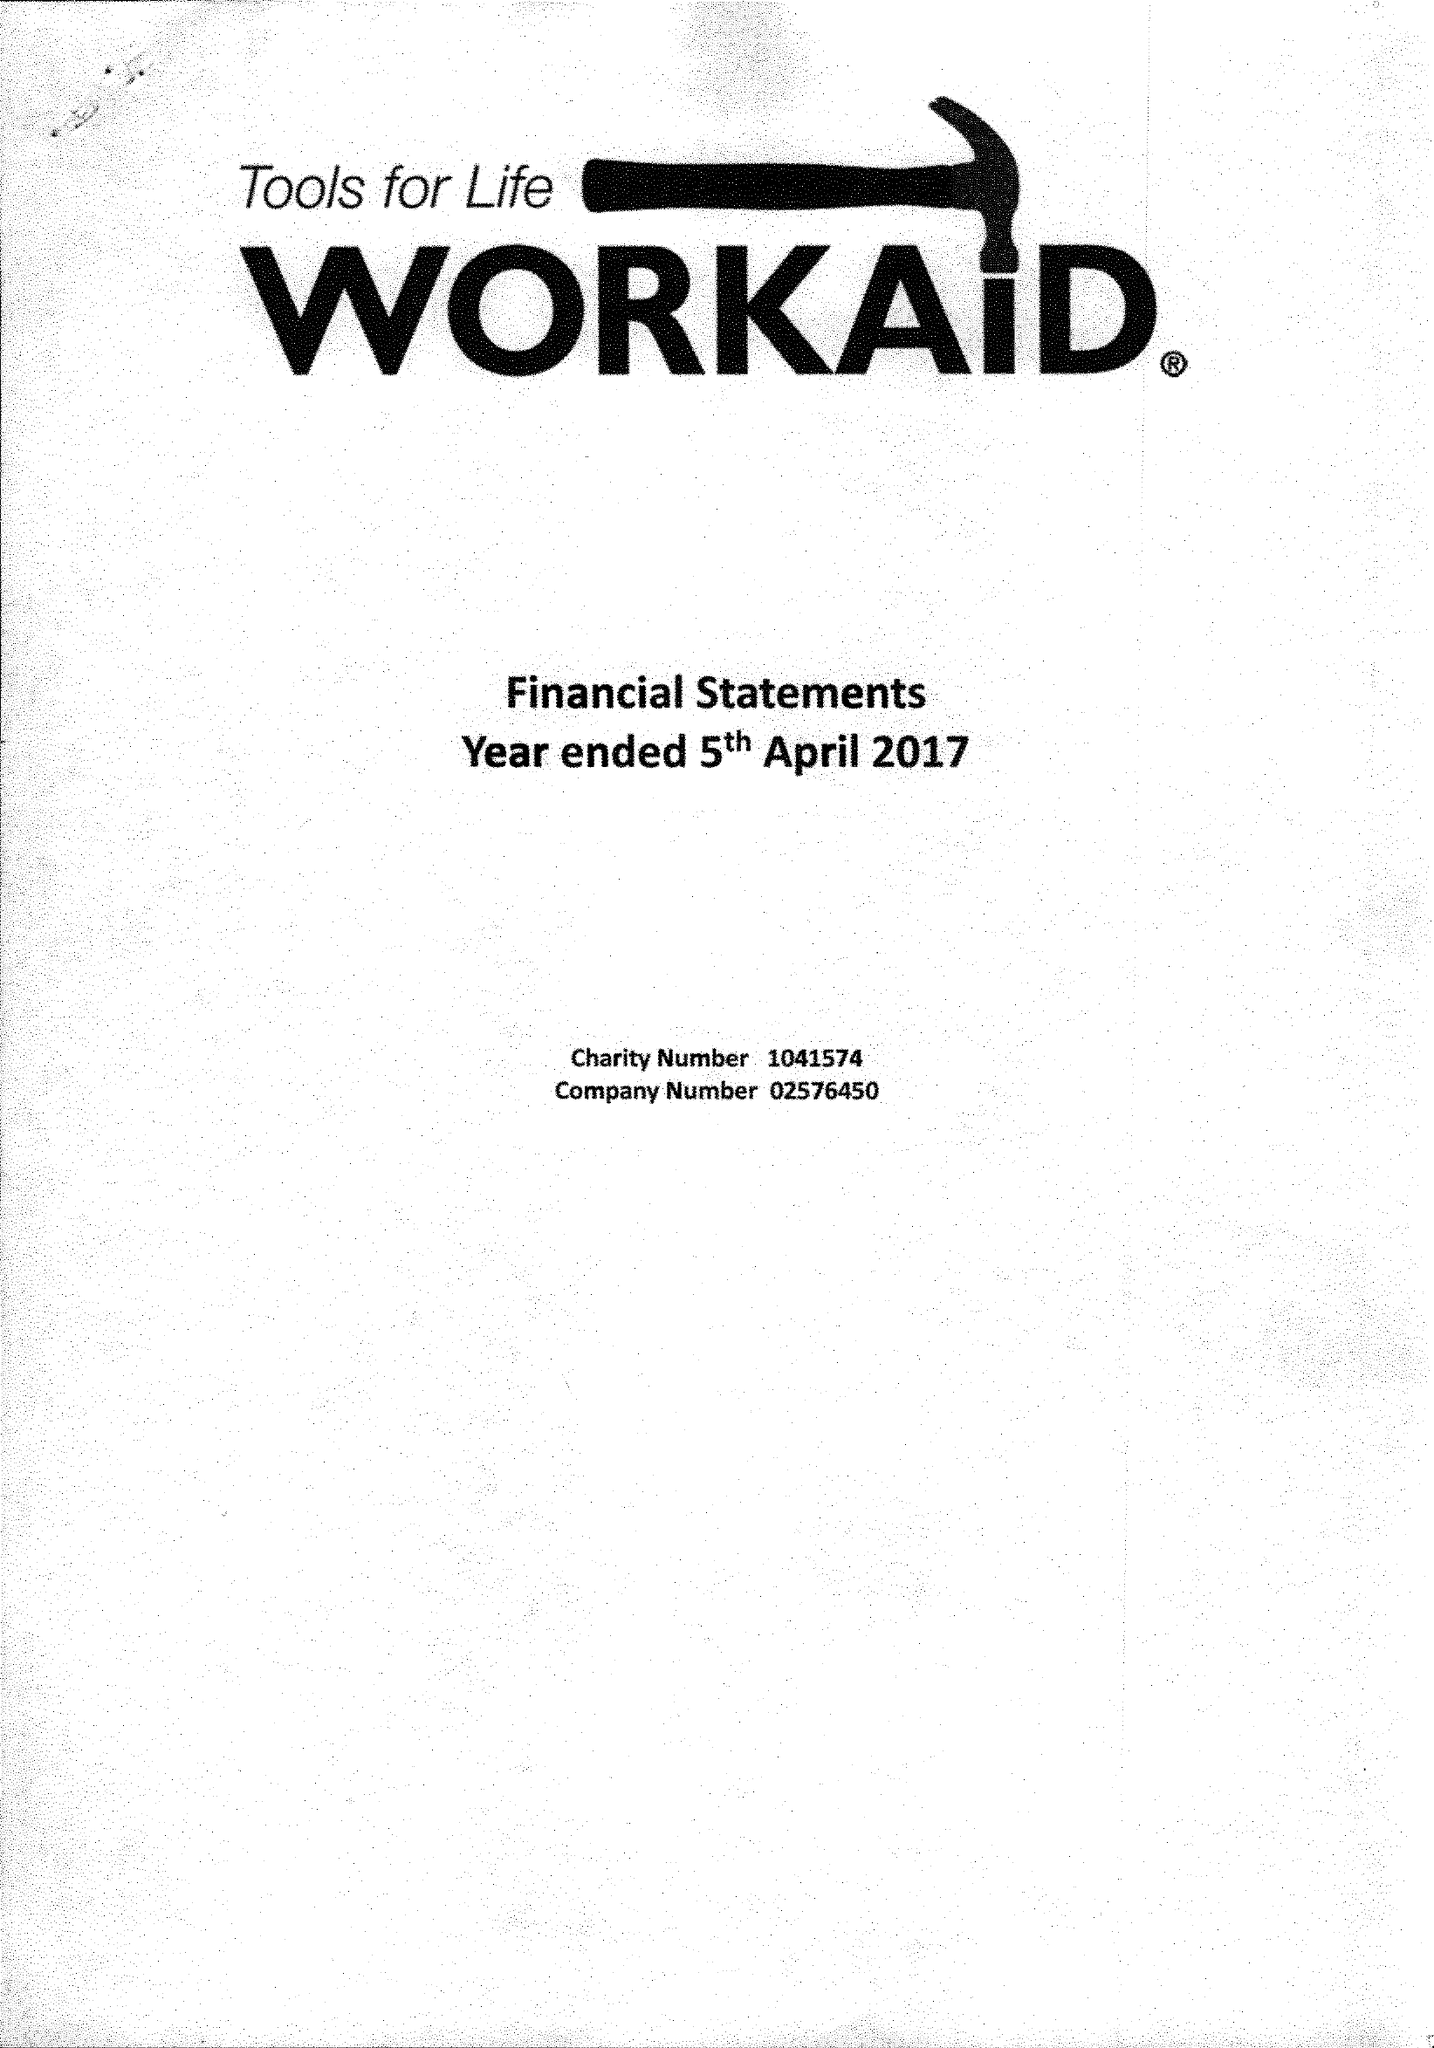What is the value for the address__postcode?
Answer the question using a single word or phrase. HP5 2AA 